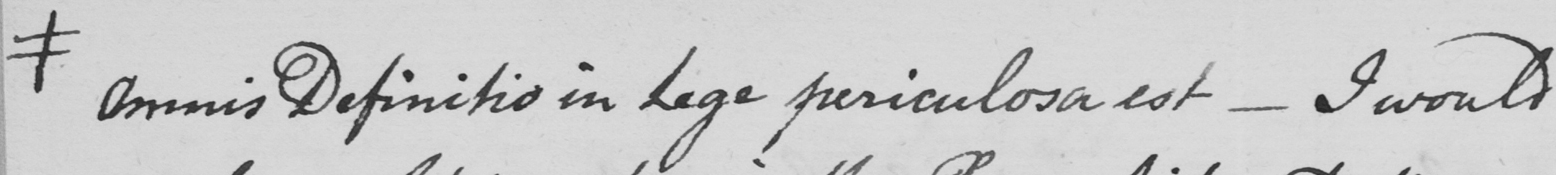What text is written in this handwritten line? # Omnis Definitio in Lege periculosa est _  I would 